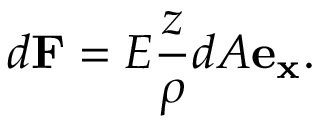Convert formula to latex. <formula><loc_0><loc_0><loc_500><loc_500>d F = E { \frac { z } { \rho } } d A e _ { x } .</formula> 